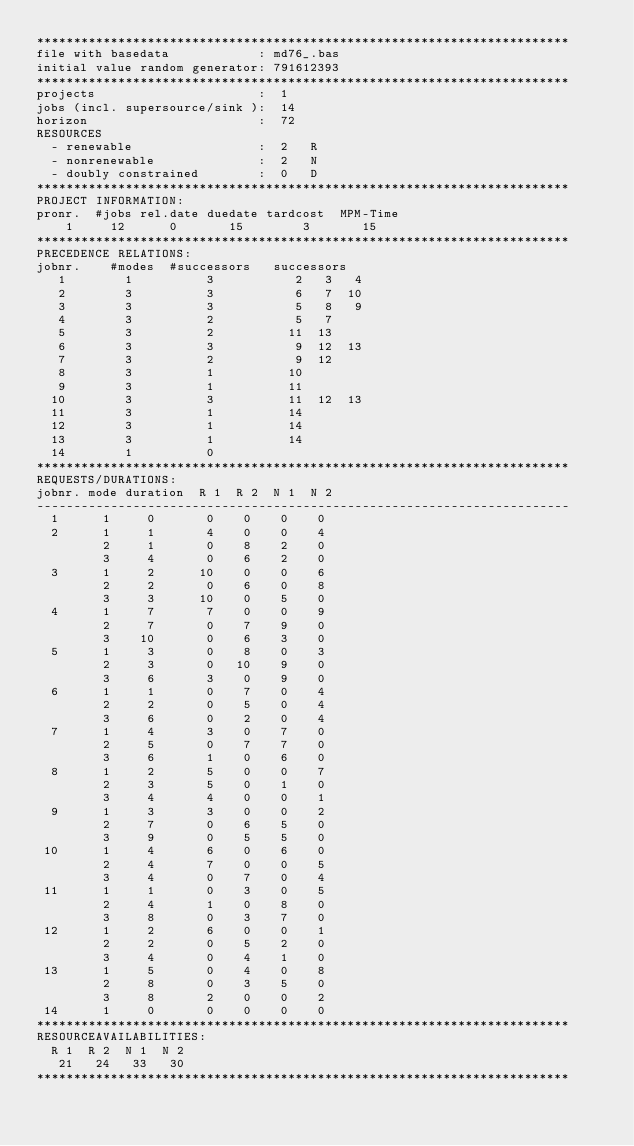Convert code to text. <code><loc_0><loc_0><loc_500><loc_500><_ObjectiveC_>************************************************************************
file with basedata            : md76_.bas
initial value random generator: 791612393
************************************************************************
projects                      :  1
jobs (incl. supersource/sink ):  14
horizon                       :  72
RESOURCES
  - renewable                 :  2   R
  - nonrenewable              :  2   N
  - doubly constrained        :  0   D
************************************************************************
PROJECT INFORMATION:
pronr.  #jobs rel.date duedate tardcost  MPM-Time
    1     12      0       15        3       15
************************************************************************
PRECEDENCE RELATIONS:
jobnr.    #modes  #successors   successors
   1        1          3           2   3   4
   2        3          3           6   7  10
   3        3          3           5   8   9
   4        3          2           5   7
   5        3          2          11  13
   6        3          3           9  12  13
   7        3          2           9  12
   8        3          1          10
   9        3          1          11
  10        3          3          11  12  13
  11        3          1          14
  12        3          1          14
  13        3          1          14
  14        1          0        
************************************************************************
REQUESTS/DURATIONS:
jobnr. mode duration  R 1  R 2  N 1  N 2
------------------------------------------------------------------------
  1      1     0       0    0    0    0
  2      1     1       4    0    0    4
         2     1       0    8    2    0
         3     4       0    6    2    0
  3      1     2      10    0    0    6
         2     2       0    6    0    8
         3     3      10    0    5    0
  4      1     7       7    0    0    9
         2     7       0    7    9    0
         3    10       0    6    3    0
  5      1     3       0    8    0    3
         2     3       0   10    9    0
         3     6       3    0    9    0
  6      1     1       0    7    0    4
         2     2       0    5    0    4
         3     6       0    2    0    4
  7      1     4       3    0    7    0
         2     5       0    7    7    0
         3     6       1    0    6    0
  8      1     2       5    0    0    7
         2     3       5    0    1    0
         3     4       4    0    0    1
  9      1     3       3    0    0    2
         2     7       0    6    5    0
         3     9       0    5    5    0
 10      1     4       6    0    6    0
         2     4       7    0    0    5
         3     4       0    7    0    4
 11      1     1       0    3    0    5
         2     4       1    0    8    0
         3     8       0    3    7    0
 12      1     2       6    0    0    1
         2     2       0    5    2    0
         3     4       0    4    1    0
 13      1     5       0    4    0    8
         2     8       0    3    5    0
         3     8       2    0    0    2
 14      1     0       0    0    0    0
************************************************************************
RESOURCEAVAILABILITIES:
  R 1  R 2  N 1  N 2
   21   24   33   30
************************************************************************
</code> 